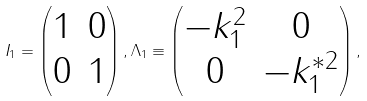<formula> <loc_0><loc_0><loc_500><loc_500>I _ { 1 } = \left ( \begin{matrix} 1 & 0 \\ 0 & 1 \end{matrix} \right ) , \Lambda _ { 1 } \equiv \left ( \begin{matrix} - k ^ { 2 } _ { 1 } & 0 \\ 0 & - k ^ { * 2 } _ { 1 } \end{matrix} \right ) ,</formula> 